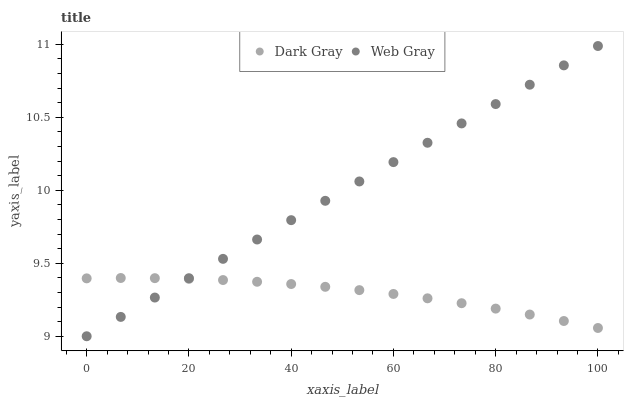Does Dark Gray have the minimum area under the curve?
Answer yes or no. Yes. Does Web Gray have the maximum area under the curve?
Answer yes or no. Yes. Does Web Gray have the minimum area under the curve?
Answer yes or no. No. Is Web Gray the smoothest?
Answer yes or no. Yes. Is Dark Gray the roughest?
Answer yes or no. Yes. Is Web Gray the roughest?
Answer yes or no. No. Does Web Gray have the lowest value?
Answer yes or no. Yes. Does Web Gray have the highest value?
Answer yes or no. Yes. Does Dark Gray intersect Web Gray?
Answer yes or no. Yes. Is Dark Gray less than Web Gray?
Answer yes or no. No. Is Dark Gray greater than Web Gray?
Answer yes or no. No. 